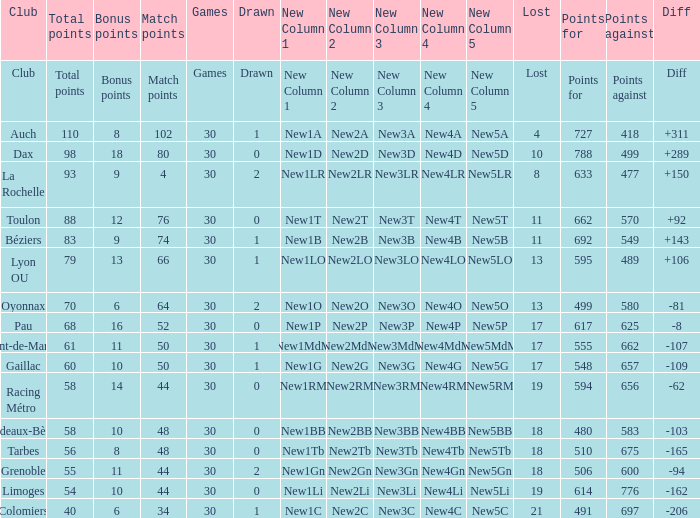How many bonus points did the Colomiers earn? 6.0. 